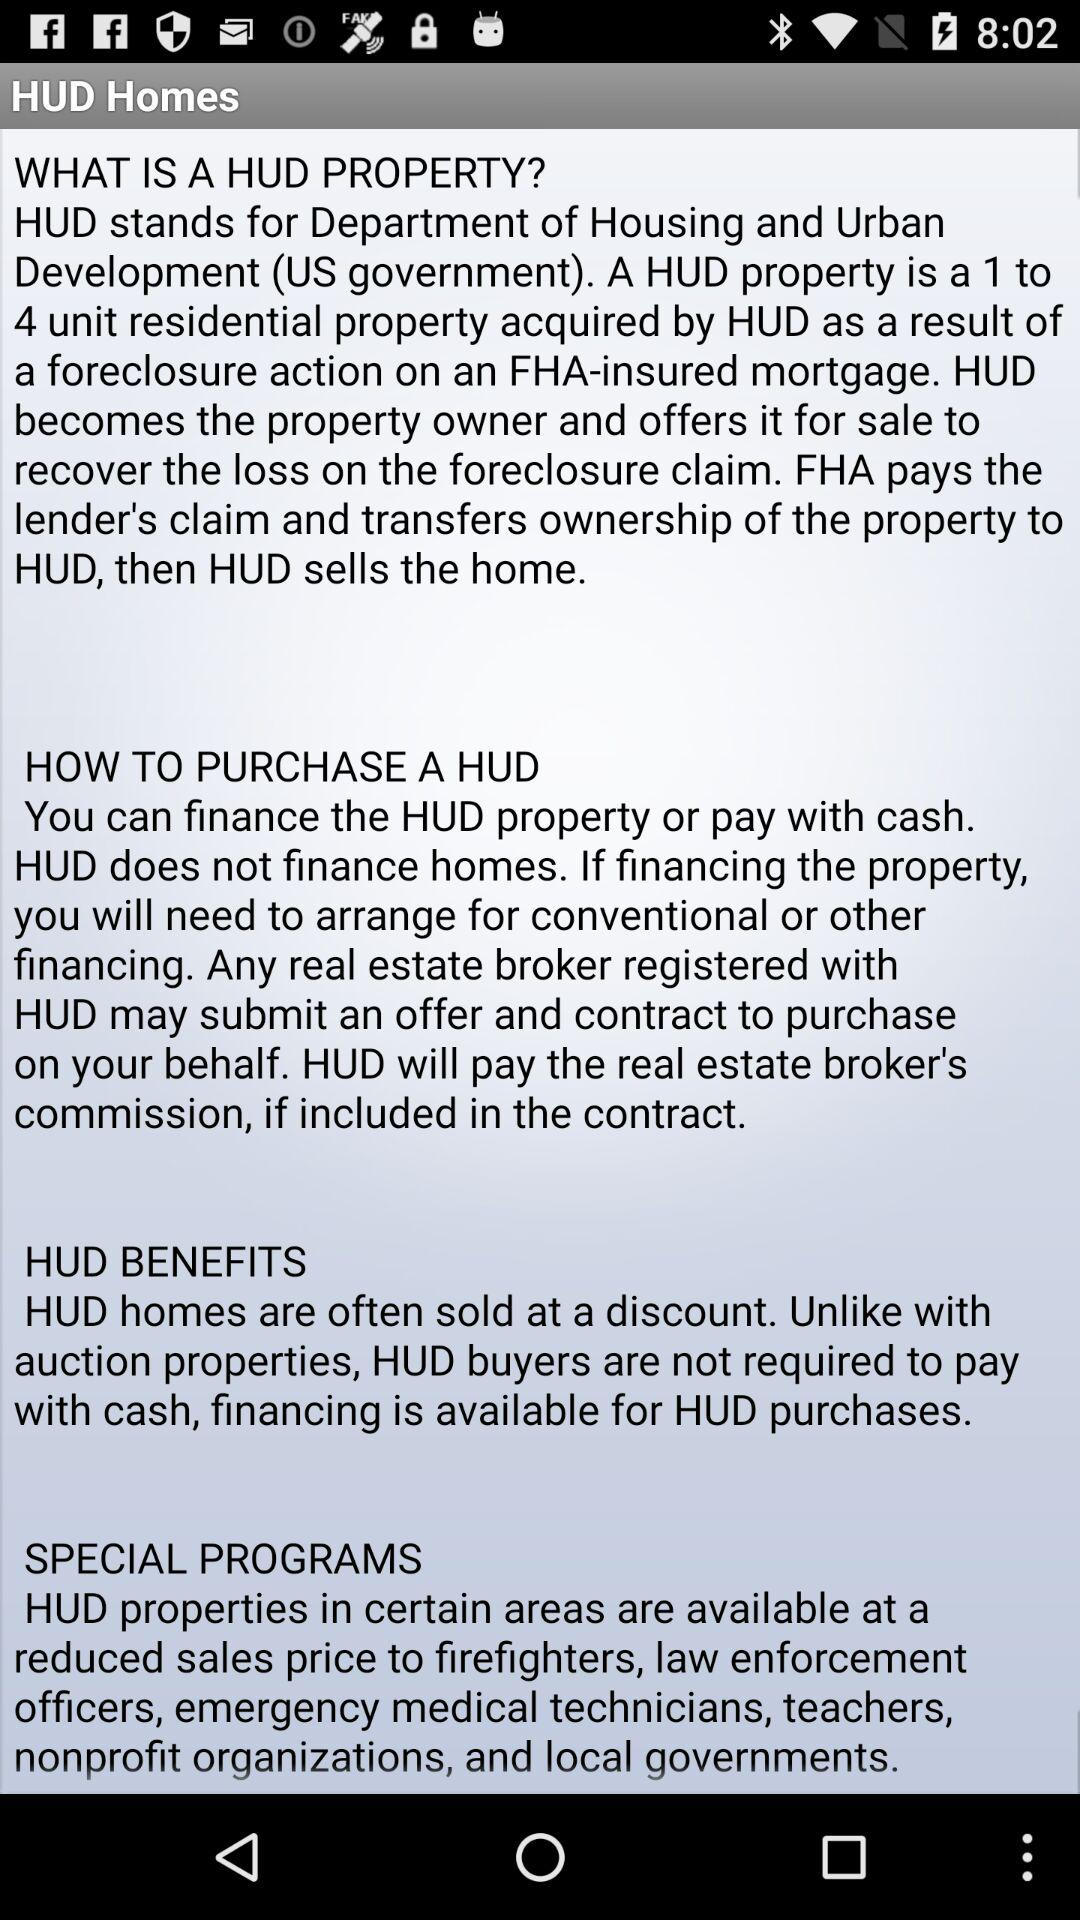What does HUD stand for? HUD stands for the Department of Housing and Urban Development. 